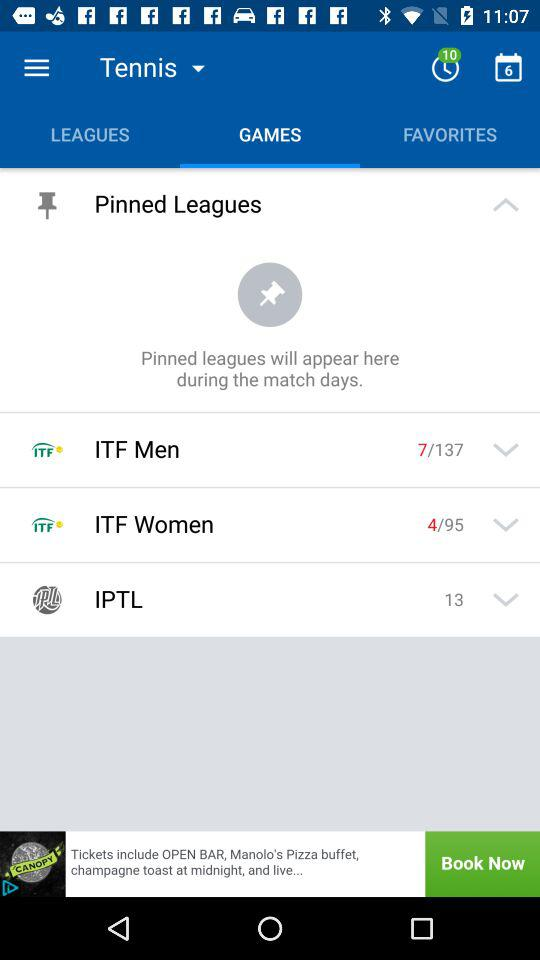What tab am I on? The tab is "GAMES". 